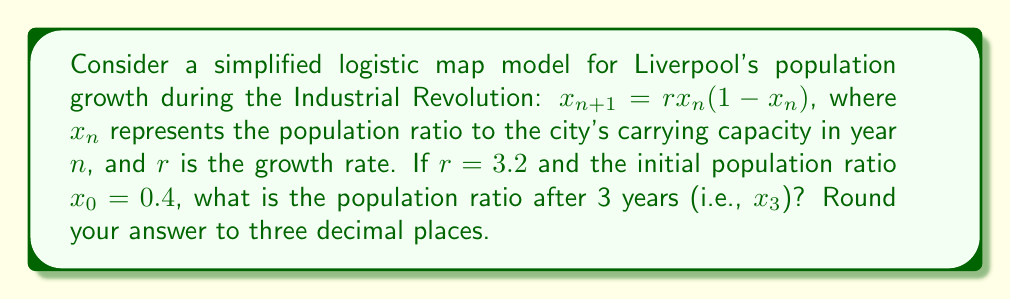Provide a solution to this math problem. To solve this problem, we need to iterate the logistic map equation for three years:

1. For year 1 ($x_1$):
   $$x_1 = r \cdot x_0 \cdot (1 - x_0)$$
   $$x_1 = 3.2 \cdot 0.4 \cdot (1 - 0.4)$$
   $$x_1 = 3.2 \cdot 0.4 \cdot 0.6 = 0.768$$

2. For year 2 ($x_2$):
   $$x_2 = r \cdot x_1 \cdot (1 - x_1)$$
   $$x_2 = 3.2 \cdot 0.768 \cdot (1 - 0.768)$$
   $$x_2 = 3.2 \cdot 0.768 \cdot 0.232 = 0.570163$$

3. For year 3 ($x_3$):
   $$x_3 = r \cdot x_2 \cdot (1 - x_2)$$
   $$x_3 = 3.2 \cdot 0.570163 \cdot (1 - 0.570163)$$
   $$x_3 = 3.2 \cdot 0.570163 \cdot 0.429837 = 0.784841$$

Rounding to three decimal places, we get 0.785.
Answer: 0.785 